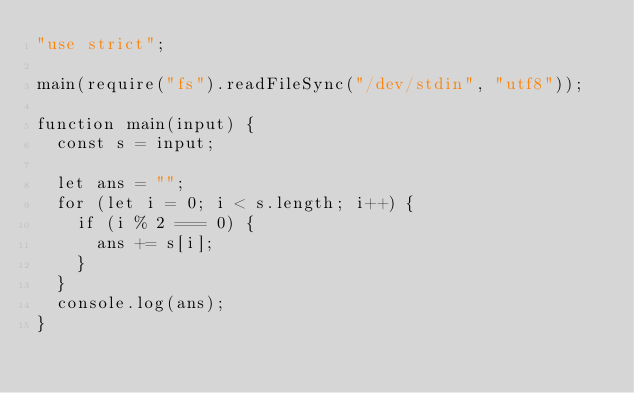<code> <loc_0><loc_0><loc_500><loc_500><_TypeScript_>"use strict";

main(require("fs").readFileSync("/dev/stdin", "utf8"));

function main(input) {
  const s = input;

  let ans = "";
  for (let i = 0; i < s.length; i++) {
    if (i % 2 === 0) {
      ans += s[i];
    }
  }
  console.log(ans);
}</code> 